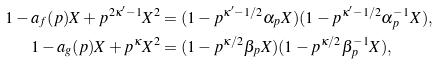Convert formula to latex. <formula><loc_0><loc_0><loc_500><loc_500>1 - a _ { f } ( p ) X + p ^ { 2 \kappa ^ { \prime } - 1 } X ^ { 2 } & = ( 1 - p ^ { \kappa ^ { \prime } - 1 / 2 } \alpha _ { p } X ) ( 1 - p ^ { \kappa ^ { \prime } - 1 / 2 } \alpha _ { p } ^ { - 1 } X ) , \\ 1 - a _ { g } ( p ) X + p ^ { \kappa } X ^ { 2 } & = ( 1 - p ^ { \kappa / 2 } \beta _ { p } X ) ( 1 - p ^ { \kappa / 2 } \beta _ { p } ^ { - 1 } X ) ,</formula> 